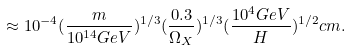<formula> <loc_0><loc_0><loc_500><loc_500>\approx 1 0 ^ { - 4 } ( \frac { m } { 1 0 ^ { 1 4 } G e V } ) ^ { 1 / 3 } ( \frac { 0 . 3 } { \Omega _ { X } } ) ^ { 1 / 3 } ( \frac { 1 0 ^ { 4 } G e V } { H } ) ^ { 1 / 2 } c m .</formula> 